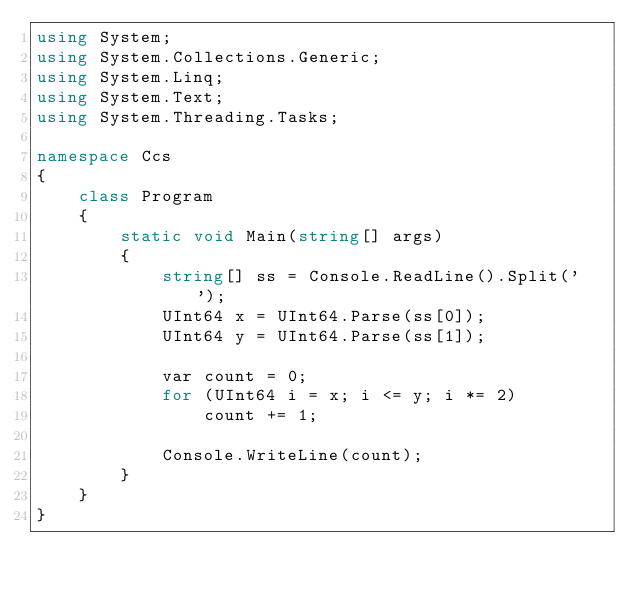<code> <loc_0><loc_0><loc_500><loc_500><_C#_>using System;
using System.Collections.Generic;
using System.Linq;
using System.Text;
using System.Threading.Tasks;

namespace Ccs
{
    class Program
    {
        static void Main(string[] args)
        {
            string[] ss = Console.ReadLine().Split(' ');
            UInt64 x = UInt64.Parse(ss[0]);
            UInt64 y = UInt64.Parse(ss[1]);

            var count = 0;
            for (UInt64 i = x; i <= y; i *= 2)
                count += 1;

            Console.WriteLine(count);
        }
    }
}
</code> 